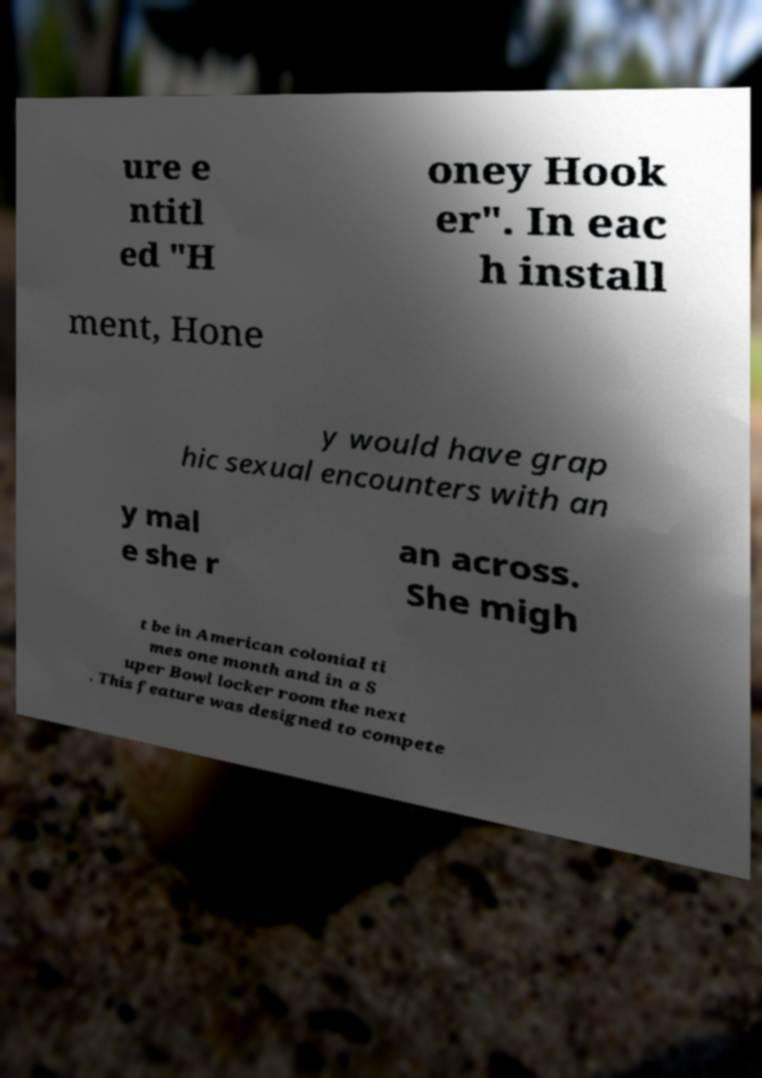Please read and relay the text visible in this image. What does it say? ure e ntitl ed "H oney Hook er". In eac h install ment, Hone y would have grap hic sexual encounters with an y mal e she r an across. She migh t be in American colonial ti mes one month and in a S uper Bowl locker room the next . This feature was designed to compete 